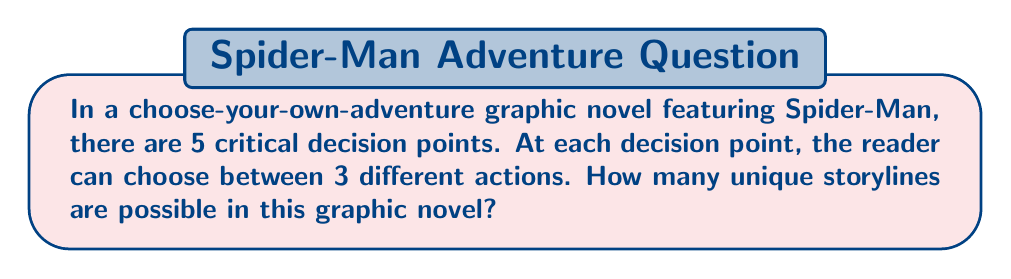Give your solution to this math problem. Let's approach this step-by-step:

1) At each decision point, the reader has 3 choices. This means we have 3 options, 5 times in a row.

2) This scenario is a perfect example of the Multiplication Principle in combinatorics. When we have a sequence of independent choices, we multiply the number of options for each choice.

3) In this case, we have:
   $$ 3 \times 3 \times 3 \times 3 \times 3 $$

4) This can be written more concisely as:
   $$ 3^5 $$

5) To calculate this:
   $$ 3^5 = 3 \times 3 \times 3 \times 3 \times 3 = 243 $$

6) Therefore, there are 243 unique storylines possible in this choose-your-own-adventure graphic novel.

This large number of possibilities demonstrates why choose-your-own-adventure books are so engaging for readers, as there are many different paths to explore!
Answer: $243$ 